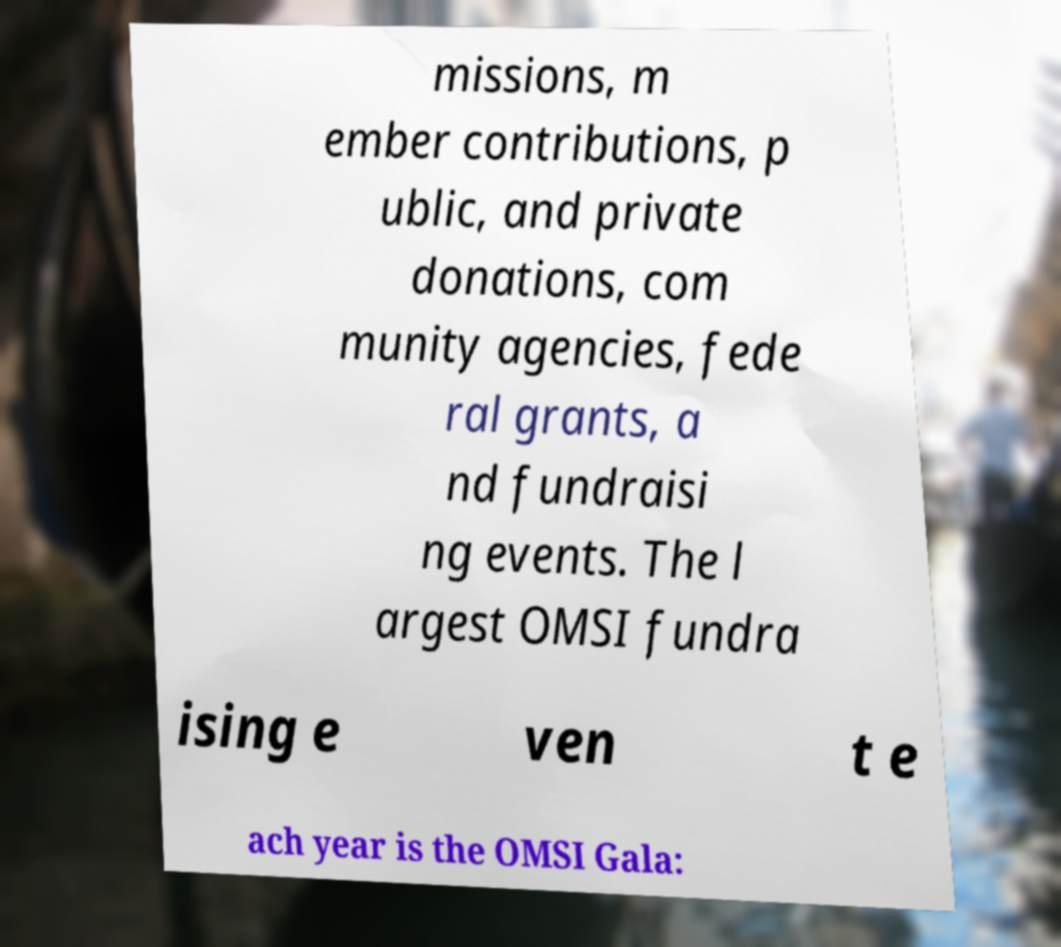For documentation purposes, I need the text within this image transcribed. Could you provide that? missions, m ember contributions, p ublic, and private donations, com munity agencies, fede ral grants, a nd fundraisi ng events. The l argest OMSI fundra ising e ven t e ach year is the OMSI Gala: 